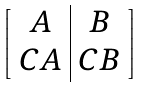<formula> <loc_0><loc_0><loc_500><loc_500>\begin{bmatrix} \begin{array} { c | c } A & B \\ C A & C B \end{array} \end{bmatrix}</formula> 